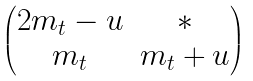Convert formula to latex. <formula><loc_0><loc_0><loc_500><loc_500>\begin{pmatrix} 2 m _ { t } - u & \ast \\ m _ { t } & m _ { t } + u \end{pmatrix}</formula> 